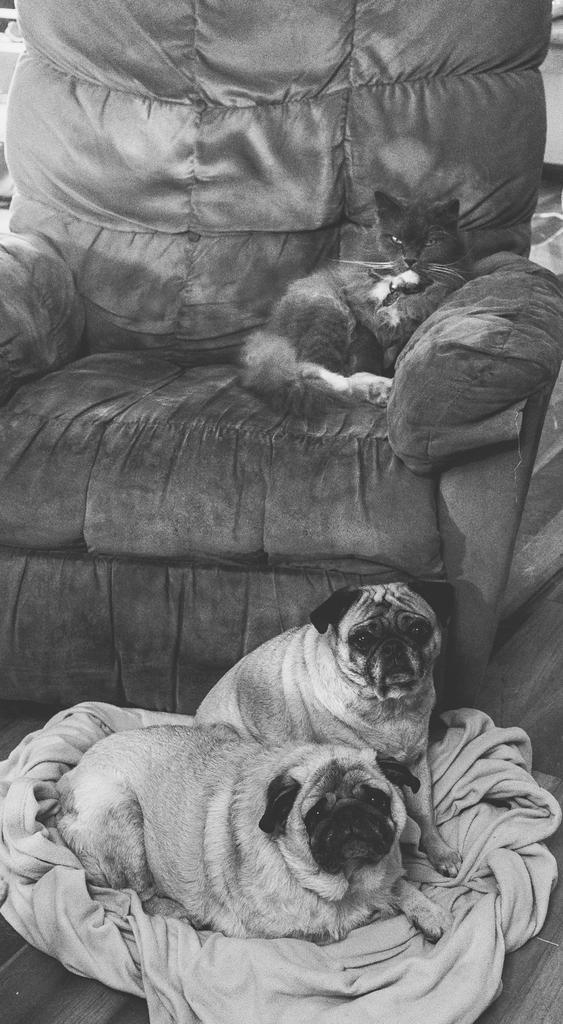Could you give a brief overview of what you see in this image? In this image I can see the black and white picture in which I can see two dogs are on the cloth. I can see a couch and on the couch I can see a cat which is black in color. 